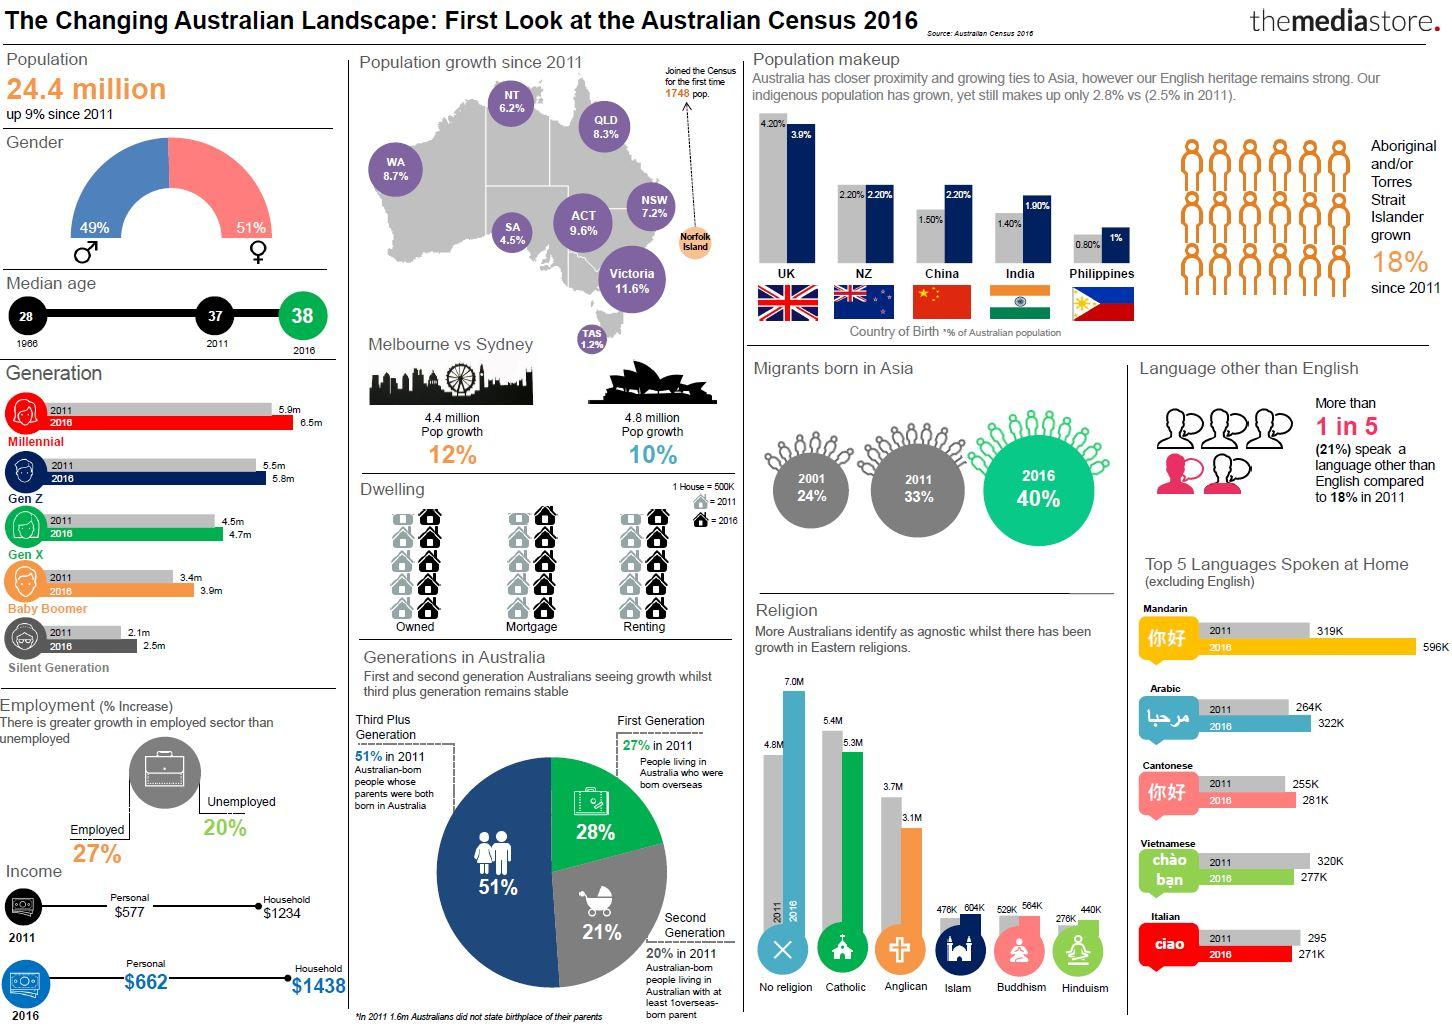Draw attention to some important aspects in this diagram. The highest number of Asian migrants ever recorded reached Australia in the year 2016. According to recent estimates, the population growth of Sydney has increased by 10%. The median age of Australians in the year 2011 was 37 years old. Sydney's population is approximately 4.8 million. According to data from the year 2011, the average household income in Australia was approximately $1234. 